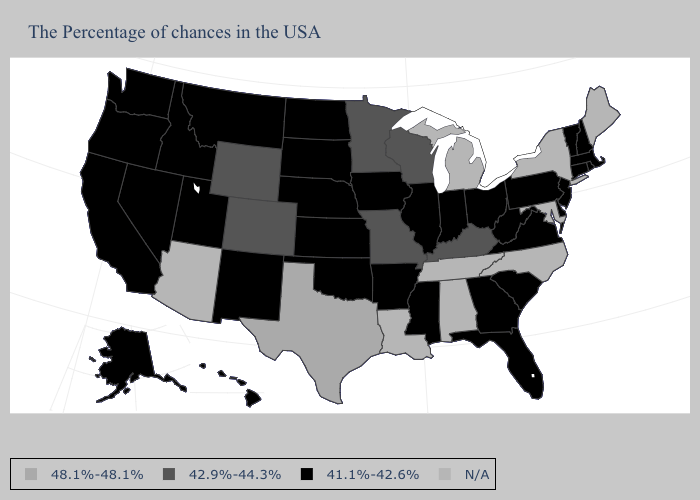What is the value of Rhode Island?
Write a very short answer. 41.1%-42.6%. Does Mississippi have the lowest value in the South?
Be succinct. Yes. How many symbols are there in the legend?
Write a very short answer. 4. What is the lowest value in states that border Washington?
Write a very short answer. 41.1%-42.6%. Name the states that have a value in the range 48.1%-48.1%?
Quick response, please. Texas. What is the highest value in states that border Idaho?
Answer briefly. 42.9%-44.3%. What is the highest value in the West ?
Short answer required. 42.9%-44.3%. Does the first symbol in the legend represent the smallest category?
Quick response, please. No. Among the states that border Illinois , does Kentucky have the highest value?
Quick response, please. Yes. What is the highest value in states that border Delaware?
Be succinct. 41.1%-42.6%. What is the value of Connecticut?
Concise answer only. 41.1%-42.6%. Which states hav the highest value in the West?
Concise answer only. Wyoming, Colorado. What is the value of Washington?
Write a very short answer. 41.1%-42.6%. Among the states that border Colorado , does Oklahoma have the lowest value?
Give a very brief answer. Yes. 